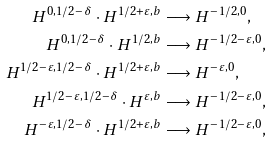Convert formula to latex. <formula><loc_0><loc_0><loc_500><loc_500>H ^ { 0 , 1 / 2 - \delta } \cdot H ^ { 1 / 2 + \varepsilon , b } & \longrightarrow H ^ { - 1 / 2 , 0 } , \\ H ^ { 0 , 1 / 2 - \delta } \cdot H ^ { 1 / 2 , b } & \longrightarrow H ^ { - 1 / 2 - \varepsilon , 0 } , \\ H ^ { 1 / 2 - \varepsilon , 1 / 2 - \delta } \cdot H ^ { 1 / 2 + \varepsilon , b } & \longrightarrow H ^ { - \varepsilon , 0 } , \\ H ^ { 1 / 2 - \varepsilon , 1 / 2 - \delta } \cdot H ^ { \varepsilon , b } & \longrightarrow H ^ { - 1 / 2 - \varepsilon , 0 } , \\ H ^ { - \varepsilon , 1 / 2 - \delta } \cdot H ^ { 1 / 2 + \varepsilon , b } & \longrightarrow H ^ { - 1 / 2 - \varepsilon , 0 } ,</formula> 